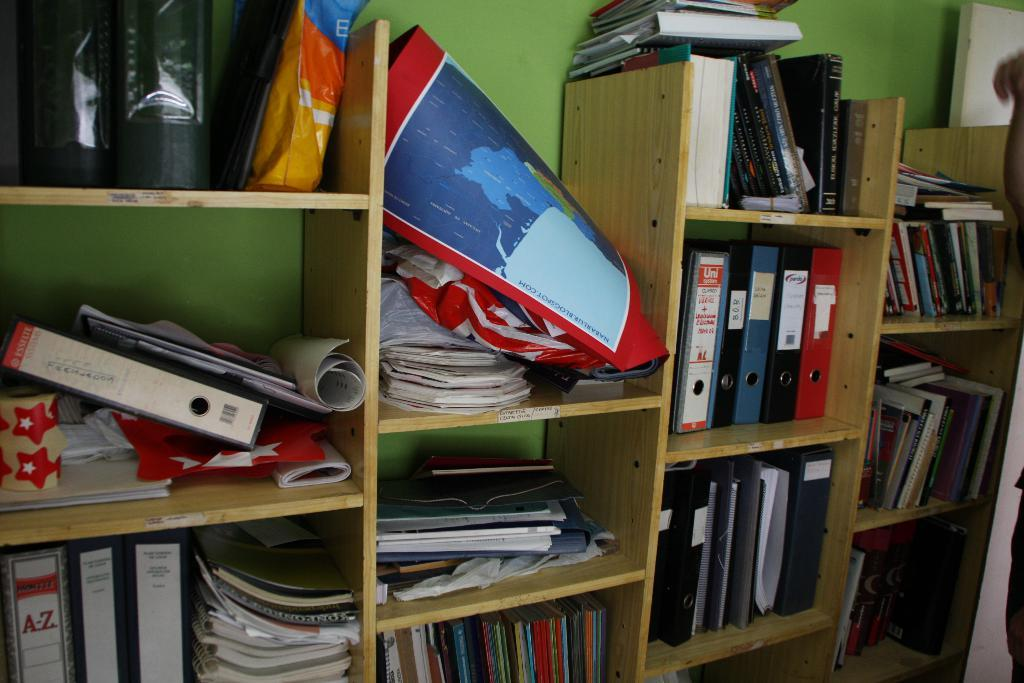Provide a one-sentence caption for the provided image. Shelf that has a book which says A-Z. 